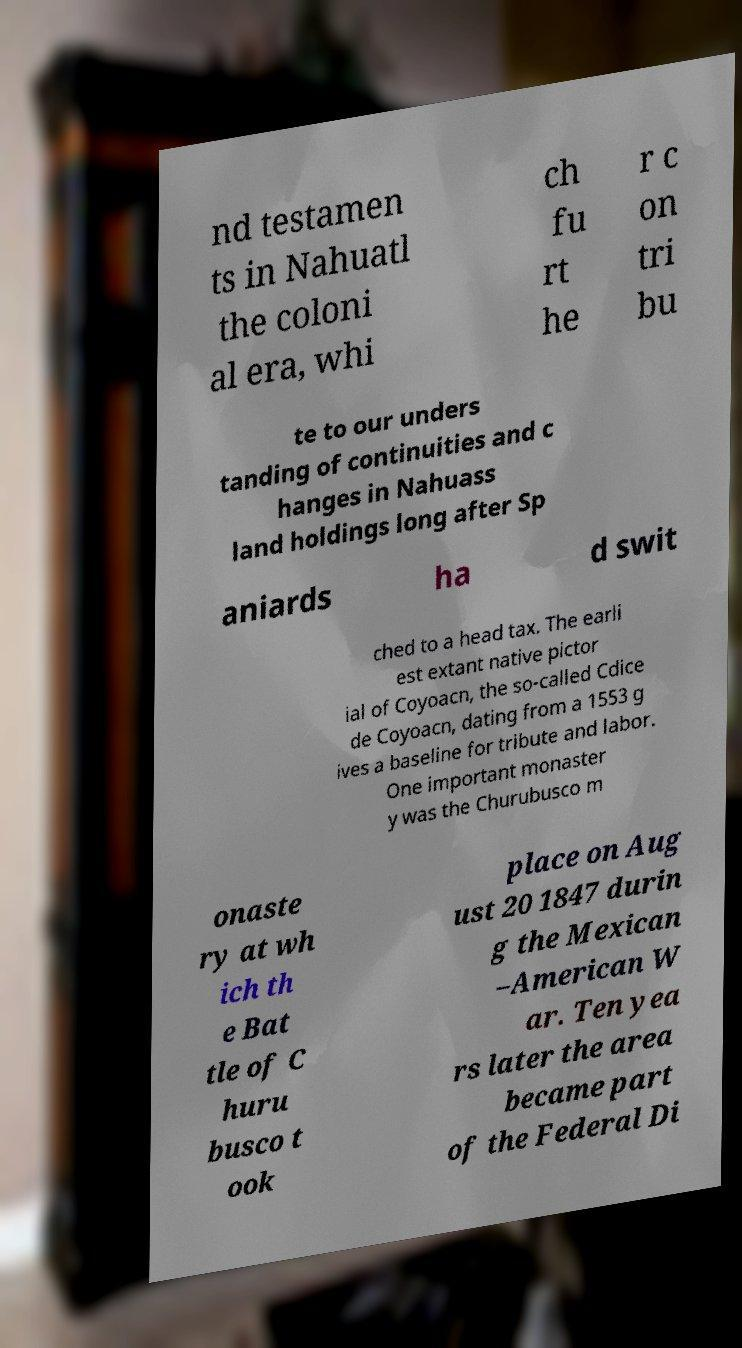Please identify and transcribe the text found in this image. nd testamen ts in Nahuatl the coloni al era, whi ch fu rt he r c on tri bu te to our unders tanding of continuities and c hanges in Nahuass land holdings long after Sp aniards ha d swit ched to a head tax. The earli est extant native pictor ial of Coyoacn, the so-called Cdice de Coyoacn, dating from a 1553 g ives a baseline for tribute and labor. One important monaster y was the Churubusco m onaste ry at wh ich th e Bat tle of C huru busco t ook place on Aug ust 20 1847 durin g the Mexican –American W ar. Ten yea rs later the area became part of the Federal Di 